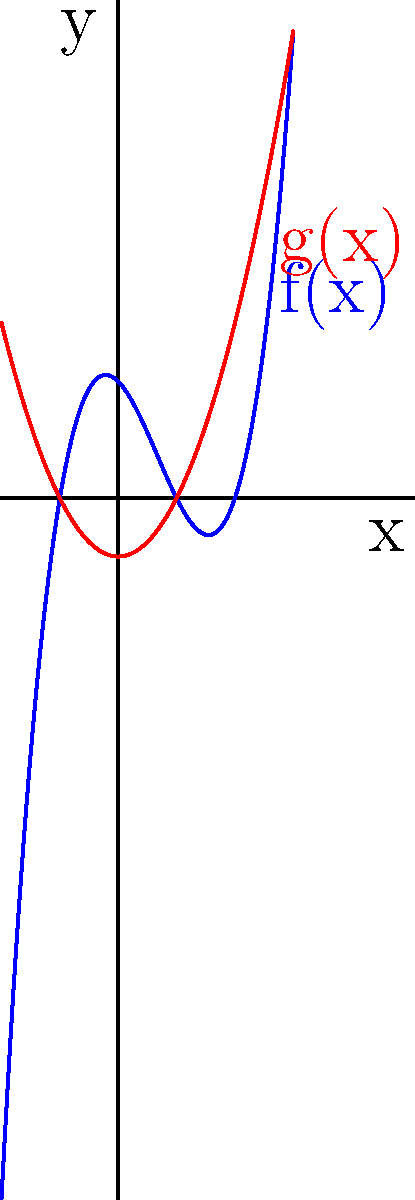Compare the blue polynomial function $f(x)$ and the red polynomial function $g(x)$ shown in the graph. Identify their differences in terms of roots, degree, and behavior. Which function has a higher degree, and how many real roots does each function have? Let's analyze the two polynomial functions step by step:

1. Degree:
   - The blue function $f(x)$ appears to be a cubic function (degree 3) due to its S-shape.
   - The red function $g(x)$ is clearly a parabola, which is a quadratic function (degree 2).

2. Roots:
   - $f(x)$ (blue) intersects the x-axis at three points, indicating three real roots.
   - $g(x)$ (red) intersects the x-axis at two points, indicating two real roots.

3. Behavior:
   - $f(x)$ starts negative, increases to a local maximum, decreases to a local minimum, then increases again.
   - $g(x)$ is a simple upward-opening parabola with a minimum point between its two roots.

4. Comparing degrees:
   $f(x)$ has a higher degree (3) compared to $g(x)$ (2).

5. Number of real roots:
   $f(x)$ has 3 real roots, while $g(x)$ has 2 real roots.
Answer: $f(x)$ has a higher degree (3); $f(x)$ has 3 real roots, $g(x)$ has 2 real roots. 